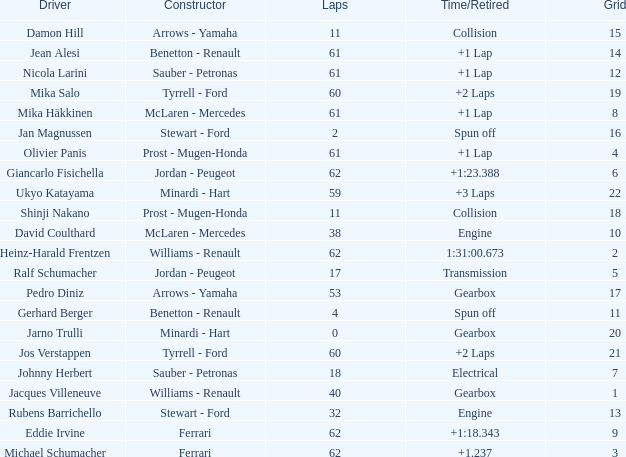What constructor has under 62 laps, a Time/Retired of gearbox, a Grid larger than 1, and pedro diniz driving? Arrows - Yamaha. 